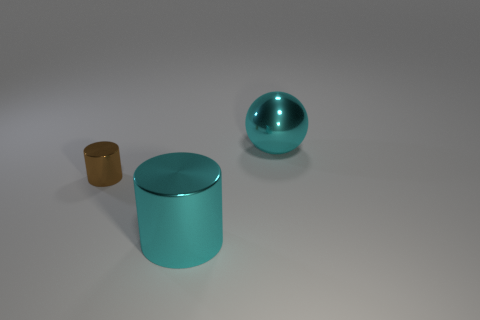Add 2 large shiny objects. How many objects exist? 5 Subtract all cyan cylinders. How many cylinders are left? 1 Subtract all red balls. Subtract all cyan cubes. How many balls are left? 1 Subtract all cyan objects. Subtract all big cyan metal balls. How many objects are left? 0 Add 3 big cyan metallic cylinders. How many big cyan metallic cylinders are left? 4 Add 3 cyan cylinders. How many cyan cylinders exist? 4 Subtract 1 brown cylinders. How many objects are left? 2 Subtract all cylinders. How many objects are left? 1 